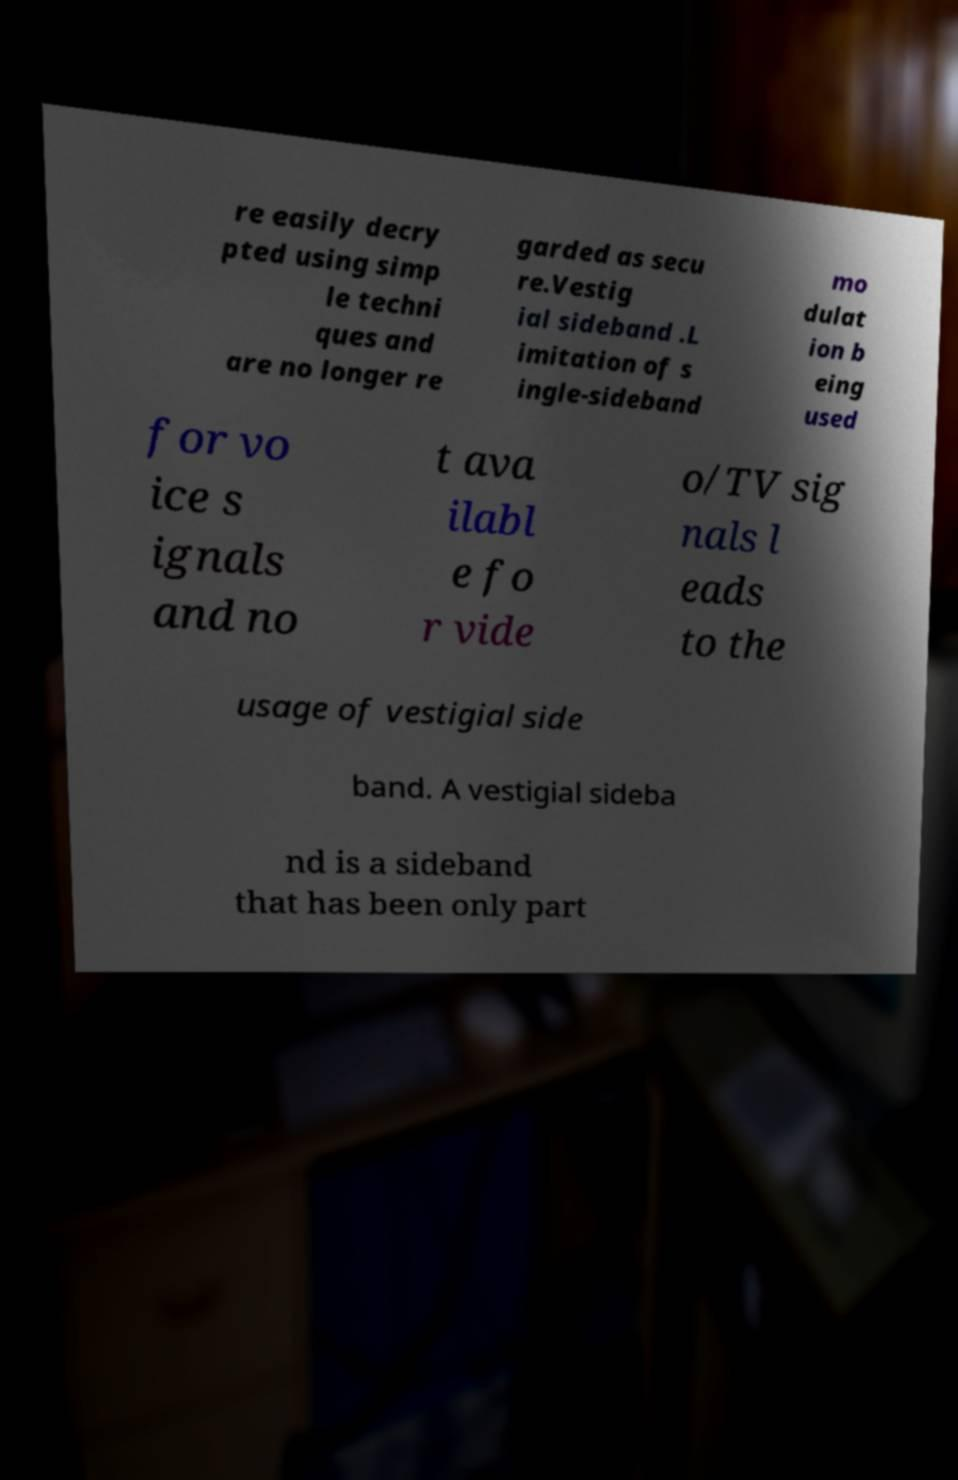For documentation purposes, I need the text within this image transcribed. Could you provide that? re easily decry pted using simp le techni ques and are no longer re garded as secu re.Vestig ial sideband .L imitation of s ingle-sideband mo dulat ion b eing used for vo ice s ignals and no t ava ilabl e fo r vide o/TV sig nals l eads to the usage of vestigial side band. A vestigial sideba nd is a sideband that has been only part 